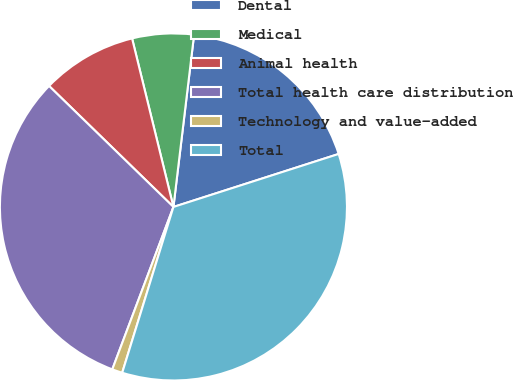Convert chart to OTSL. <chart><loc_0><loc_0><loc_500><loc_500><pie_chart><fcel>Dental<fcel>Medical<fcel>Animal health<fcel>Total health care distribution<fcel>Technology and value-added<fcel>Total<nl><fcel>18.16%<fcel>5.73%<fcel>8.89%<fcel>31.55%<fcel>0.96%<fcel>34.71%<nl></chart> 